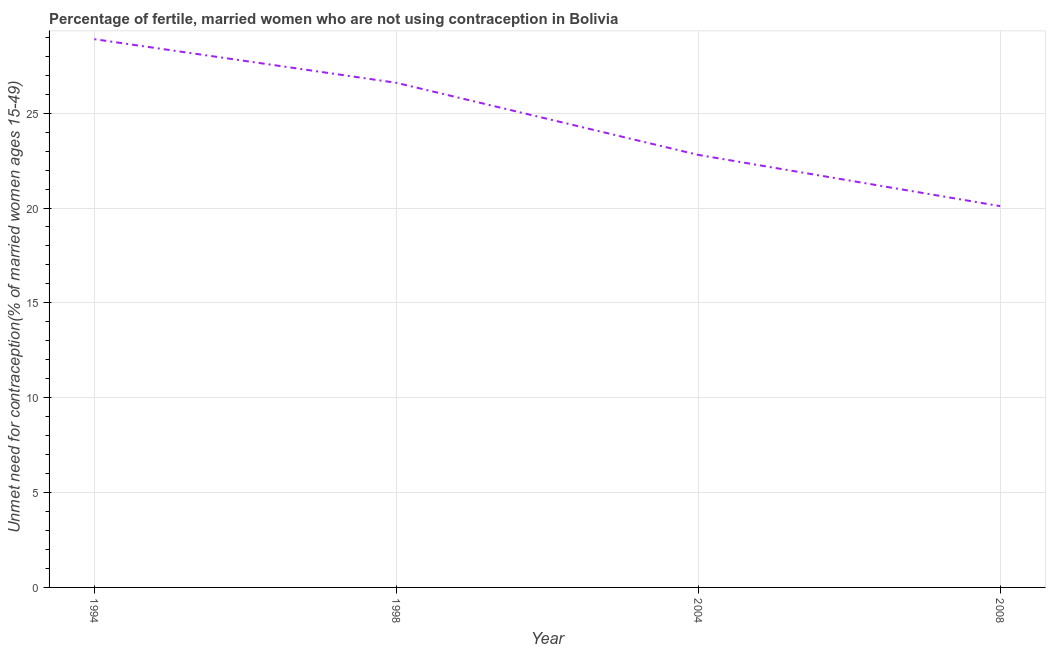What is the number of married women who are not using contraception in 1998?
Make the answer very short. 26.6. Across all years, what is the maximum number of married women who are not using contraception?
Your response must be concise. 28.9. Across all years, what is the minimum number of married women who are not using contraception?
Give a very brief answer. 20.1. In which year was the number of married women who are not using contraception maximum?
Your response must be concise. 1994. In which year was the number of married women who are not using contraception minimum?
Keep it short and to the point. 2008. What is the sum of the number of married women who are not using contraception?
Ensure brevity in your answer.  98.4. What is the difference between the number of married women who are not using contraception in 1994 and 2008?
Your answer should be compact. 8.8. What is the average number of married women who are not using contraception per year?
Keep it short and to the point. 24.6. What is the median number of married women who are not using contraception?
Your answer should be compact. 24.7. In how many years, is the number of married women who are not using contraception greater than 12 %?
Offer a very short reply. 4. What is the ratio of the number of married women who are not using contraception in 1994 to that in 2004?
Ensure brevity in your answer.  1.27. Is the difference between the number of married women who are not using contraception in 1994 and 2008 greater than the difference between any two years?
Make the answer very short. Yes. What is the difference between the highest and the second highest number of married women who are not using contraception?
Your answer should be very brief. 2.3. What is the difference between the highest and the lowest number of married women who are not using contraception?
Your answer should be very brief. 8.8. In how many years, is the number of married women who are not using contraception greater than the average number of married women who are not using contraception taken over all years?
Offer a very short reply. 2. How many years are there in the graph?
Your answer should be very brief. 4. Are the values on the major ticks of Y-axis written in scientific E-notation?
Your answer should be compact. No. Does the graph contain any zero values?
Your answer should be very brief. No. What is the title of the graph?
Your response must be concise. Percentage of fertile, married women who are not using contraception in Bolivia. What is the label or title of the X-axis?
Your answer should be very brief. Year. What is the label or title of the Y-axis?
Offer a very short reply.  Unmet need for contraception(% of married women ages 15-49). What is the  Unmet need for contraception(% of married women ages 15-49) in 1994?
Provide a succinct answer. 28.9. What is the  Unmet need for contraception(% of married women ages 15-49) in 1998?
Provide a short and direct response. 26.6. What is the  Unmet need for contraception(% of married women ages 15-49) in 2004?
Your response must be concise. 22.8. What is the  Unmet need for contraception(% of married women ages 15-49) in 2008?
Provide a short and direct response. 20.1. What is the difference between the  Unmet need for contraception(% of married women ages 15-49) in 1994 and 1998?
Your answer should be very brief. 2.3. What is the ratio of the  Unmet need for contraception(% of married women ages 15-49) in 1994 to that in 1998?
Give a very brief answer. 1.09. What is the ratio of the  Unmet need for contraception(% of married women ages 15-49) in 1994 to that in 2004?
Your answer should be very brief. 1.27. What is the ratio of the  Unmet need for contraception(% of married women ages 15-49) in 1994 to that in 2008?
Offer a terse response. 1.44. What is the ratio of the  Unmet need for contraception(% of married women ages 15-49) in 1998 to that in 2004?
Provide a short and direct response. 1.17. What is the ratio of the  Unmet need for contraception(% of married women ages 15-49) in 1998 to that in 2008?
Your answer should be very brief. 1.32. What is the ratio of the  Unmet need for contraception(% of married women ages 15-49) in 2004 to that in 2008?
Ensure brevity in your answer.  1.13. 